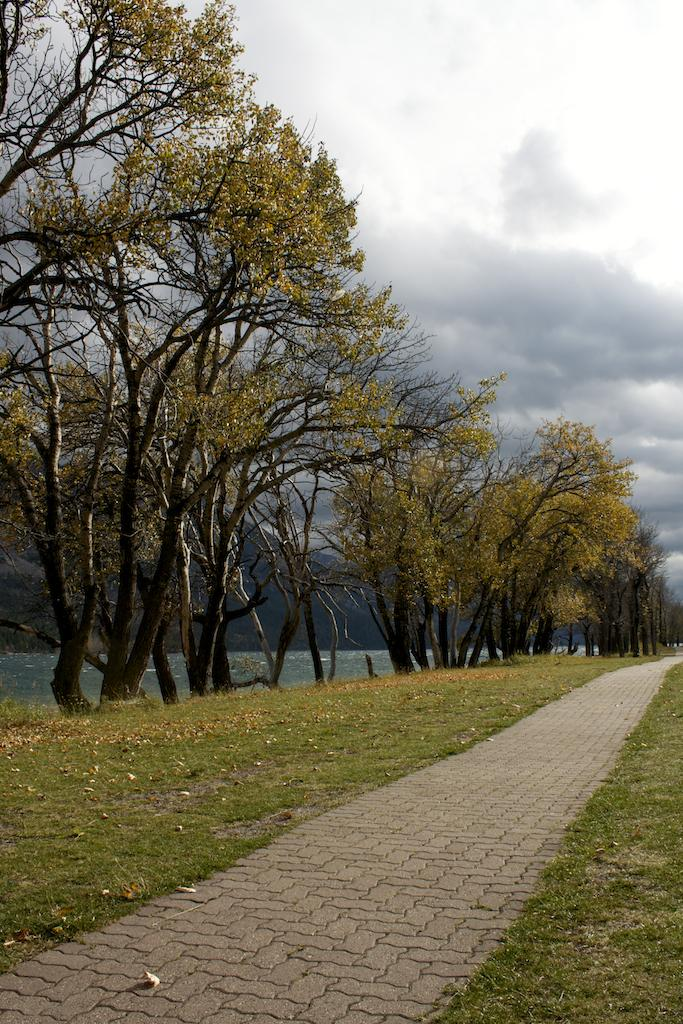What is the main subject of the image? The image displays a beautiful view of a garden. What can be seen in the foreground of the image? There is a walking area in the ground in front. What type of vegetation is visible in the background of the image? Many trees are visible behind the walking area. How would you describe the sky in the image? The sky appears cloudy in the image. Where is the bed located in the image? There is no bed present in the image; it features a garden view. What type of dirt can be seen on the ground in the image? The image does not show any dirt on the ground; it displays a garden with a walking area. 